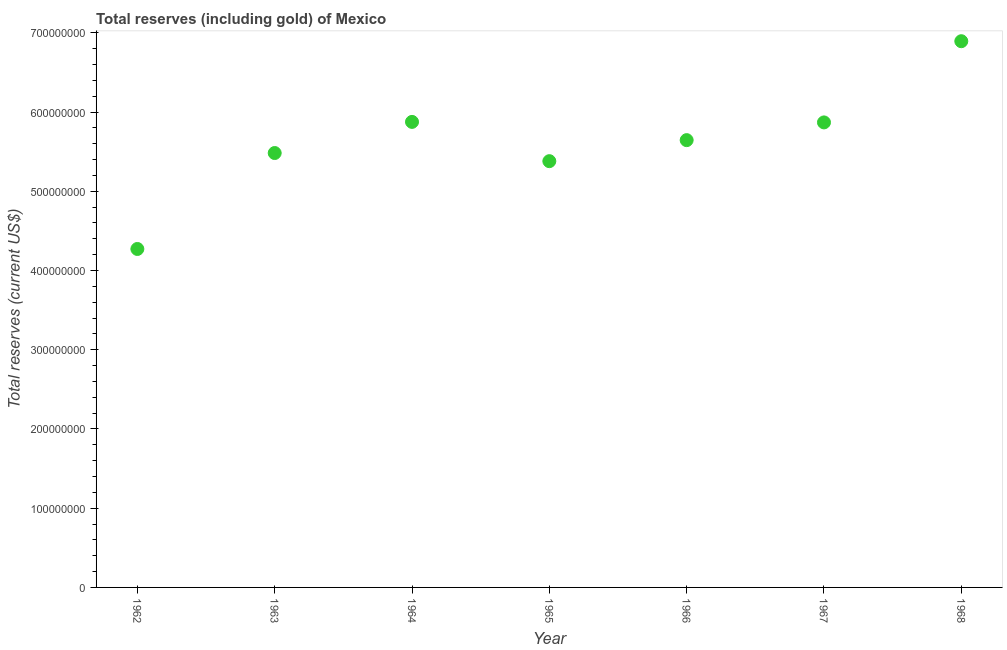What is the total reserves (including gold) in 1965?
Offer a very short reply. 5.38e+08. Across all years, what is the maximum total reserves (including gold)?
Offer a terse response. 6.89e+08. Across all years, what is the minimum total reserves (including gold)?
Offer a very short reply. 4.27e+08. In which year was the total reserves (including gold) maximum?
Offer a terse response. 1968. In which year was the total reserves (including gold) minimum?
Make the answer very short. 1962. What is the sum of the total reserves (including gold)?
Give a very brief answer. 3.94e+09. What is the difference between the total reserves (including gold) in 1963 and 1966?
Make the answer very short. -1.63e+07. What is the average total reserves (including gold) per year?
Keep it short and to the point. 5.63e+08. What is the median total reserves (including gold)?
Offer a terse response. 5.65e+08. What is the ratio of the total reserves (including gold) in 1962 to that in 1968?
Provide a succinct answer. 0.62. What is the difference between the highest and the second highest total reserves (including gold)?
Your answer should be very brief. 1.02e+08. What is the difference between the highest and the lowest total reserves (including gold)?
Ensure brevity in your answer.  2.62e+08. In how many years, is the total reserves (including gold) greater than the average total reserves (including gold) taken over all years?
Your answer should be very brief. 4. Does the total reserves (including gold) monotonically increase over the years?
Ensure brevity in your answer.  No. What is the difference between two consecutive major ticks on the Y-axis?
Provide a short and direct response. 1.00e+08. Are the values on the major ticks of Y-axis written in scientific E-notation?
Ensure brevity in your answer.  No. Does the graph contain grids?
Keep it short and to the point. No. What is the title of the graph?
Offer a terse response. Total reserves (including gold) of Mexico. What is the label or title of the X-axis?
Your answer should be compact. Year. What is the label or title of the Y-axis?
Offer a very short reply. Total reserves (current US$). What is the Total reserves (current US$) in 1962?
Your answer should be very brief. 4.27e+08. What is the Total reserves (current US$) in 1963?
Provide a succinct answer. 5.48e+08. What is the Total reserves (current US$) in 1964?
Give a very brief answer. 5.88e+08. What is the Total reserves (current US$) in 1965?
Offer a very short reply. 5.38e+08. What is the Total reserves (current US$) in 1966?
Your response must be concise. 5.65e+08. What is the Total reserves (current US$) in 1967?
Keep it short and to the point. 5.87e+08. What is the Total reserves (current US$) in 1968?
Ensure brevity in your answer.  6.89e+08. What is the difference between the Total reserves (current US$) in 1962 and 1963?
Provide a short and direct response. -1.21e+08. What is the difference between the Total reserves (current US$) in 1962 and 1964?
Offer a very short reply. -1.60e+08. What is the difference between the Total reserves (current US$) in 1962 and 1965?
Make the answer very short. -1.11e+08. What is the difference between the Total reserves (current US$) in 1962 and 1966?
Make the answer very short. -1.37e+08. What is the difference between the Total reserves (current US$) in 1962 and 1967?
Your response must be concise. -1.60e+08. What is the difference between the Total reserves (current US$) in 1962 and 1968?
Give a very brief answer. -2.62e+08. What is the difference between the Total reserves (current US$) in 1963 and 1964?
Provide a succinct answer. -3.93e+07. What is the difference between the Total reserves (current US$) in 1963 and 1965?
Keep it short and to the point. 1.03e+07. What is the difference between the Total reserves (current US$) in 1963 and 1966?
Provide a succinct answer. -1.63e+07. What is the difference between the Total reserves (current US$) in 1963 and 1967?
Ensure brevity in your answer.  -3.87e+07. What is the difference between the Total reserves (current US$) in 1963 and 1968?
Give a very brief answer. -1.41e+08. What is the difference between the Total reserves (current US$) in 1964 and 1965?
Provide a succinct answer. 4.96e+07. What is the difference between the Total reserves (current US$) in 1964 and 1966?
Your answer should be very brief. 2.30e+07. What is the difference between the Total reserves (current US$) in 1964 and 1967?
Ensure brevity in your answer.  6.41e+05. What is the difference between the Total reserves (current US$) in 1964 and 1968?
Provide a short and direct response. -1.02e+08. What is the difference between the Total reserves (current US$) in 1965 and 1966?
Provide a short and direct response. -2.65e+07. What is the difference between the Total reserves (current US$) in 1965 and 1967?
Provide a succinct answer. -4.89e+07. What is the difference between the Total reserves (current US$) in 1965 and 1968?
Your answer should be very brief. -1.51e+08. What is the difference between the Total reserves (current US$) in 1966 and 1967?
Offer a very short reply. -2.24e+07. What is the difference between the Total reserves (current US$) in 1966 and 1968?
Ensure brevity in your answer.  -1.25e+08. What is the difference between the Total reserves (current US$) in 1967 and 1968?
Keep it short and to the point. -1.02e+08. What is the ratio of the Total reserves (current US$) in 1962 to that in 1963?
Provide a succinct answer. 0.78. What is the ratio of the Total reserves (current US$) in 1962 to that in 1964?
Keep it short and to the point. 0.73. What is the ratio of the Total reserves (current US$) in 1962 to that in 1965?
Offer a very short reply. 0.79. What is the ratio of the Total reserves (current US$) in 1962 to that in 1966?
Your answer should be very brief. 0.76. What is the ratio of the Total reserves (current US$) in 1962 to that in 1967?
Provide a succinct answer. 0.73. What is the ratio of the Total reserves (current US$) in 1962 to that in 1968?
Give a very brief answer. 0.62. What is the ratio of the Total reserves (current US$) in 1963 to that in 1964?
Your answer should be compact. 0.93. What is the ratio of the Total reserves (current US$) in 1963 to that in 1965?
Ensure brevity in your answer.  1.02. What is the ratio of the Total reserves (current US$) in 1963 to that in 1967?
Keep it short and to the point. 0.93. What is the ratio of the Total reserves (current US$) in 1963 to that in 1968?
Your answer should be compact. 0.8. What is the ratio of the Total reserves (current US$) in 1964 to that in 1965?
Your response must be concise. 1.09. What is the ratio of the Total reserves (current US$) in 1964 to that in 1966?
Ensure brevity in your answer.  1.04. What is the ratio of the Total reserves (current US$) in 1964 to that in 1967?
Provide a succinct answer. 1. What is the ratio of the Total reserves (current US$) in 1964 to that in 1968?
Offer a terse response. 0.85. What is the ratio of the Total reserves (current US$) in 1965 to that in 1966?
Offer a terse response. 0.95. What is the ratio of the Total reserves (current US$) in 1965 to that in 1967?
Offer a very short reply. 0.92. What is the ratio of the Total reserves (current US$) in 1965 to that in 1968?
Provide a short and direct response. 0.78. What is the ratio of the Total reserves (current US$) in 1966 to that in 1967?
Offer a very short reply. 0.96. What is the ratio of the Total reserves (current US$) in 1966 to that in 1968?
Make the answer very short. 0.82. What is the ratio of the Total reserves (current US$) in 1967 to that in 1968?
Keep it short and to the point. 0.85. 